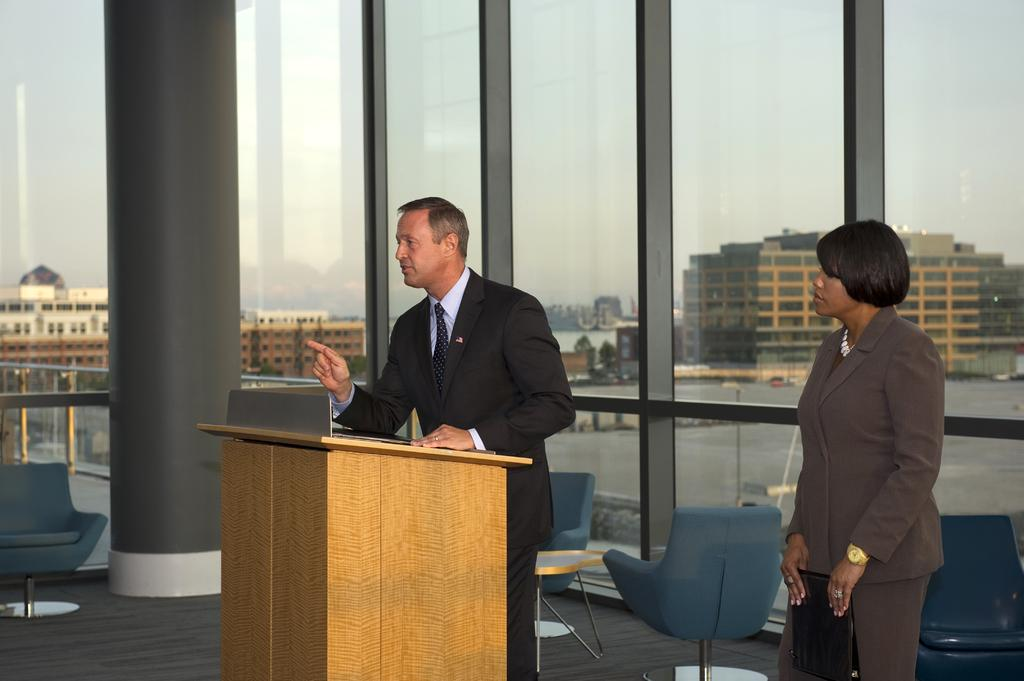How many people are present in the image? There is a man and a woman standing in the image. What objects can be seen in the image? There is a podium chair and a table in the image. What is visible in the background of the image? There are buildings in the background of the image. Is the man smoking a cigarette in the image? There is no indication of smoking or a cigarette in the image. Can you see the woman smashing the table in the image? There is no indication of smashing or any destructive behavior in the image. 